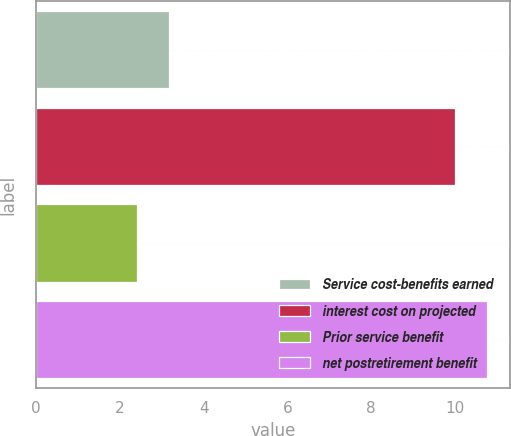Convert chart. <chart><loc_0><loc_0><loc_500><loc_500><bar_chart><fcel>Service cost-benefits earned<fcel>interest cost on projected<fcel>Prior service benefit<fcel>net postretirement benefit<nl><fcel>3.17<fcel>10<fcel>2.4<fcel>10.77<nl></chart> 